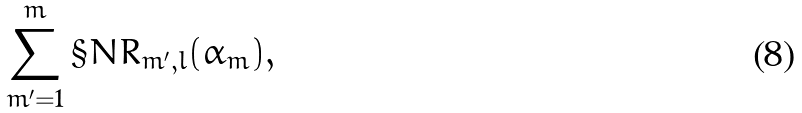Convert formula to latex. <formula><loc_0><loc_0><loc_500><loc_500>\sum _ { m ^ { \prime } = 1 } ^ { m } \S N R _ { m ^ { \prime } , l } ( \alpha _ { m } ) ,</formula> 